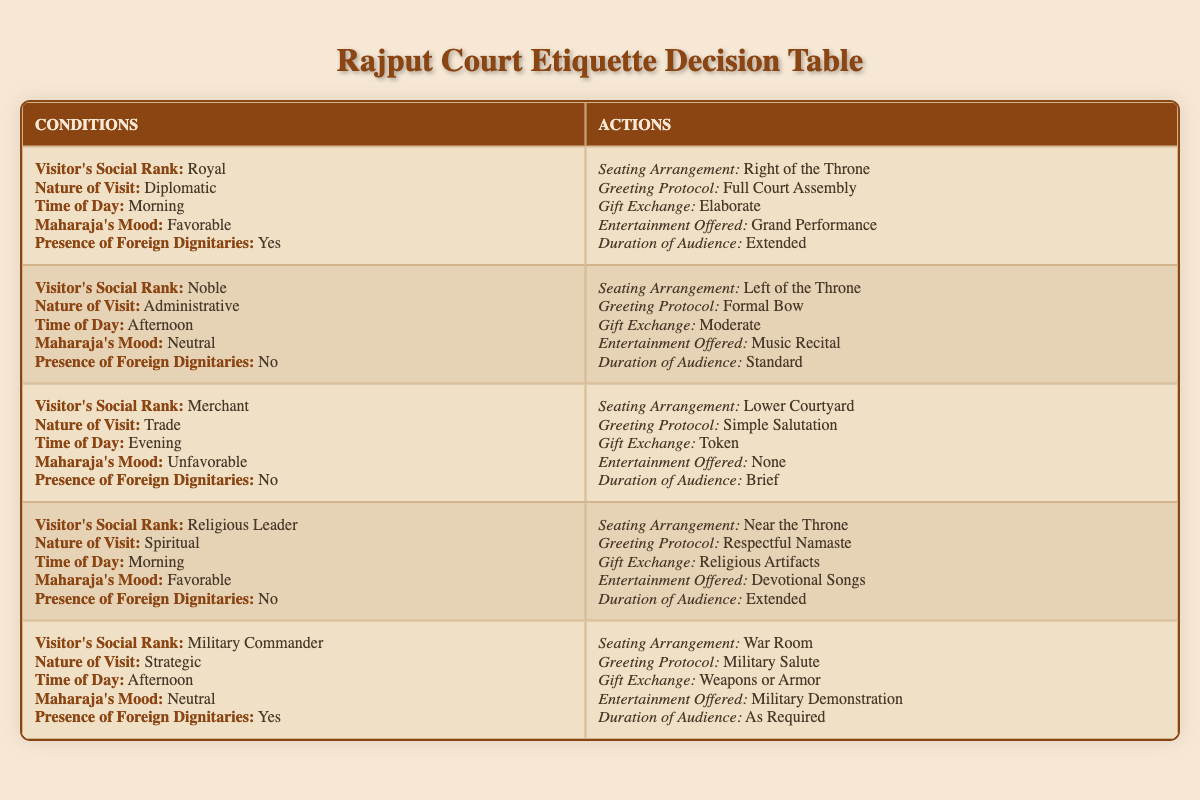What is the seating arrangement for a royal visitor during a diplomatic morning visit with favorable Maharaja's mood and the presence of foreign dignitaries? According to the table, for a visitor of royal social rank, during a diplomatic nature of visit in the morning when the Maharaja's mood is favorable and foreign dignitaries are present, the seating arrangement is "Right of the Throne."
Answer: Right of the Throne What type of entertainment is offered for a religious leader during a spiritual morning visit in the absence of foreign dignitaries? The table indicates that for a religious leader visiting for spiritual purposes in the morning with a favorable Maharaja's mood and no foreign dignitaries present, the entertainment offered is "Devotional Songs."
Answer: Devotional Songs Are gifts exchanged during a merchant's evening visit when the Maharaja's mood is unfavorable and there are no foreign dignitaries? From the data, the rules state that for a merchant's visit in the evening with an unfavorable Maharaja's mood and no foreign dignitaries, the gift exchange is categorized as a "Token." This confirms that gifts are exchanged, albeit in a minimal form.
Answer: Yes What is the duration of the audience for a military commander during a strategic afternoon visit in the presence of foreign dignitaries? The table mentions that for a military commander's visit of a strategic nature in the afternoon with a neutral Maharaja's mood and the presence of foreign dignitaries, the duration of the audience is "As Required." This indicates that the duration is flexible based on circumstances.
Answer: As Required If a noble visits in the afternoon for administrative reasons in the absence of foreign dignitaries, what greeting protocol is followed? The data specifies that when a noble visits for administrative reasons in the afternoon with a neutral Maharaja's mood and no foreign dignitaries, the greeting protocol followed is a "Formal Bow." This implies a customary respect expected in such situations.
Answer: Formal Bow How does the seating arrangement for a military commander differ from that of a noble during their respective morning visits? The table shows that during a military commander's strategic visit in the afternoon, the seating arrangement is "War Room," while a noble's administrative visit in the afternoon results in a seating arrangement to the "Left of the Throne." Thus, both have distinct seating placements dependent on their roles and the context of the visit.
Answer: War Room vs. Left of the Throne What can be concluded about the presence of foreign dignitaries during gift exchanges for a royal visitor? The data states that in the case of a royal visitor, during a diplomatic) visit in the morning with favorable Maharaja's mood and the presence of foreign dignitaries, the gift exchange is "Elaborate." Therefore, the presence of foreign dignitaries seems to enhance the significance of the gift exchange.
Answer: Elaborate What is the difference in seating arrangements between a merchant and a religious leader during their respective visits? For a merchant's evening visit when the Maharaja's mood is unfavorable, the seating arrangement is "Lower Courtyard." In contrast, for a religious leader's spiritual morning visit with a favorable mood, the seating is "Near the Throne." This demonstrates a hierarchy where spiritual visitors are given more prominence compared to merchants.
Answer: Lower Courtyard vs. Near the Throne 